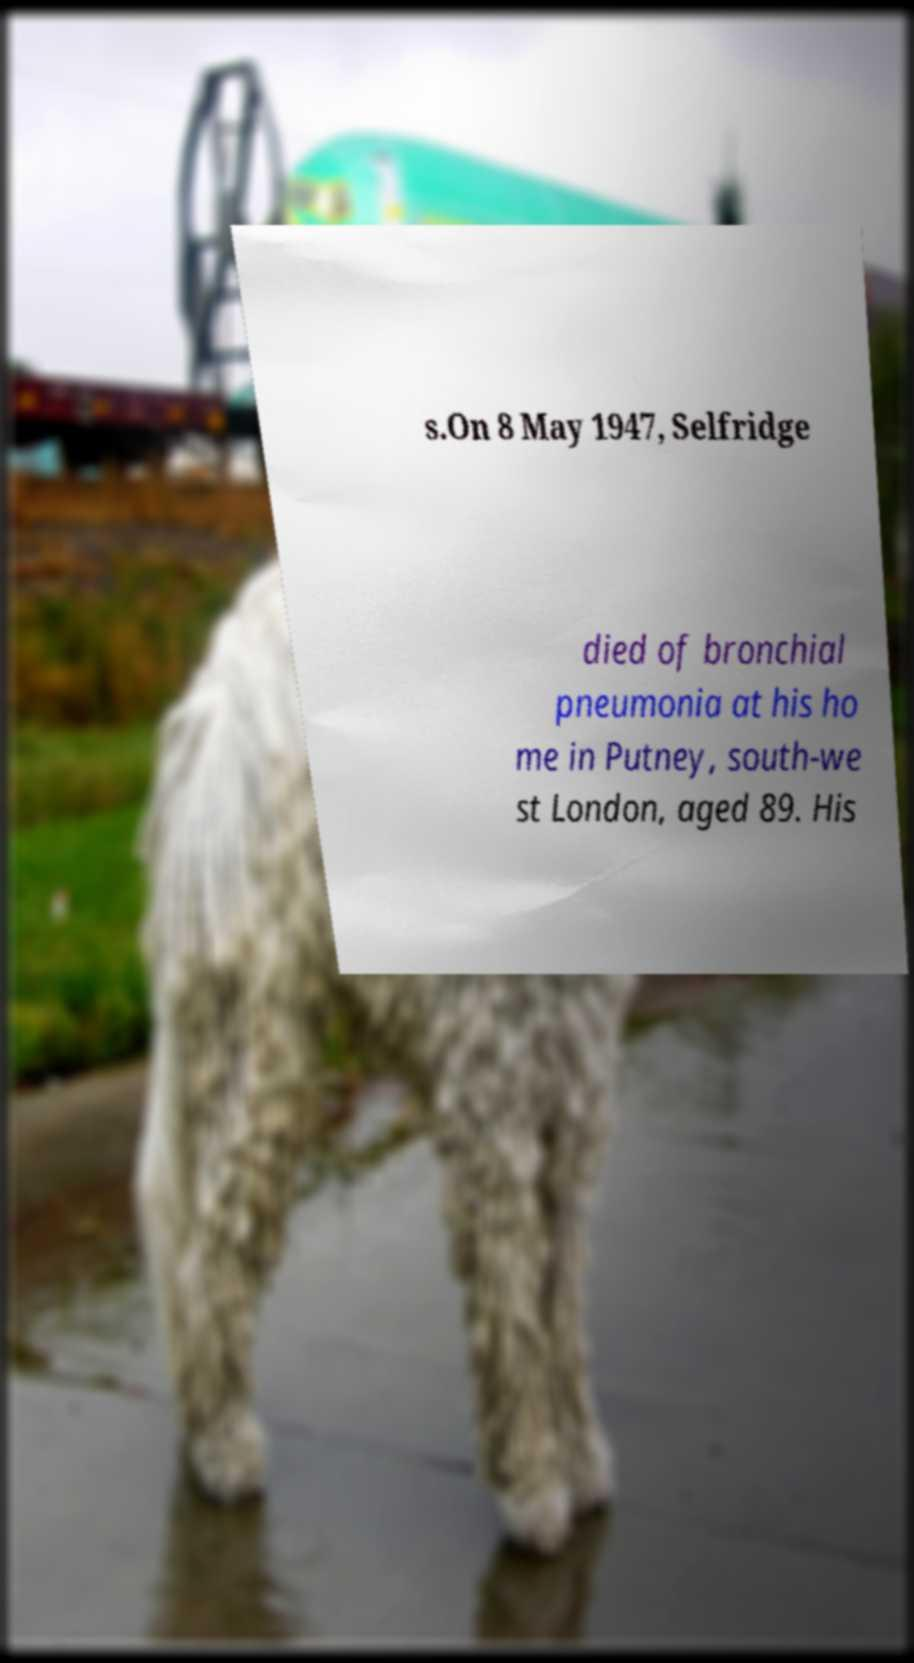Can you accurately transcribe the text from the provided image for me? s.On 8 May 1947, Selfridge died of bronchial pneumonia at his ho me in Putney, south-we st London, aged 89. His 